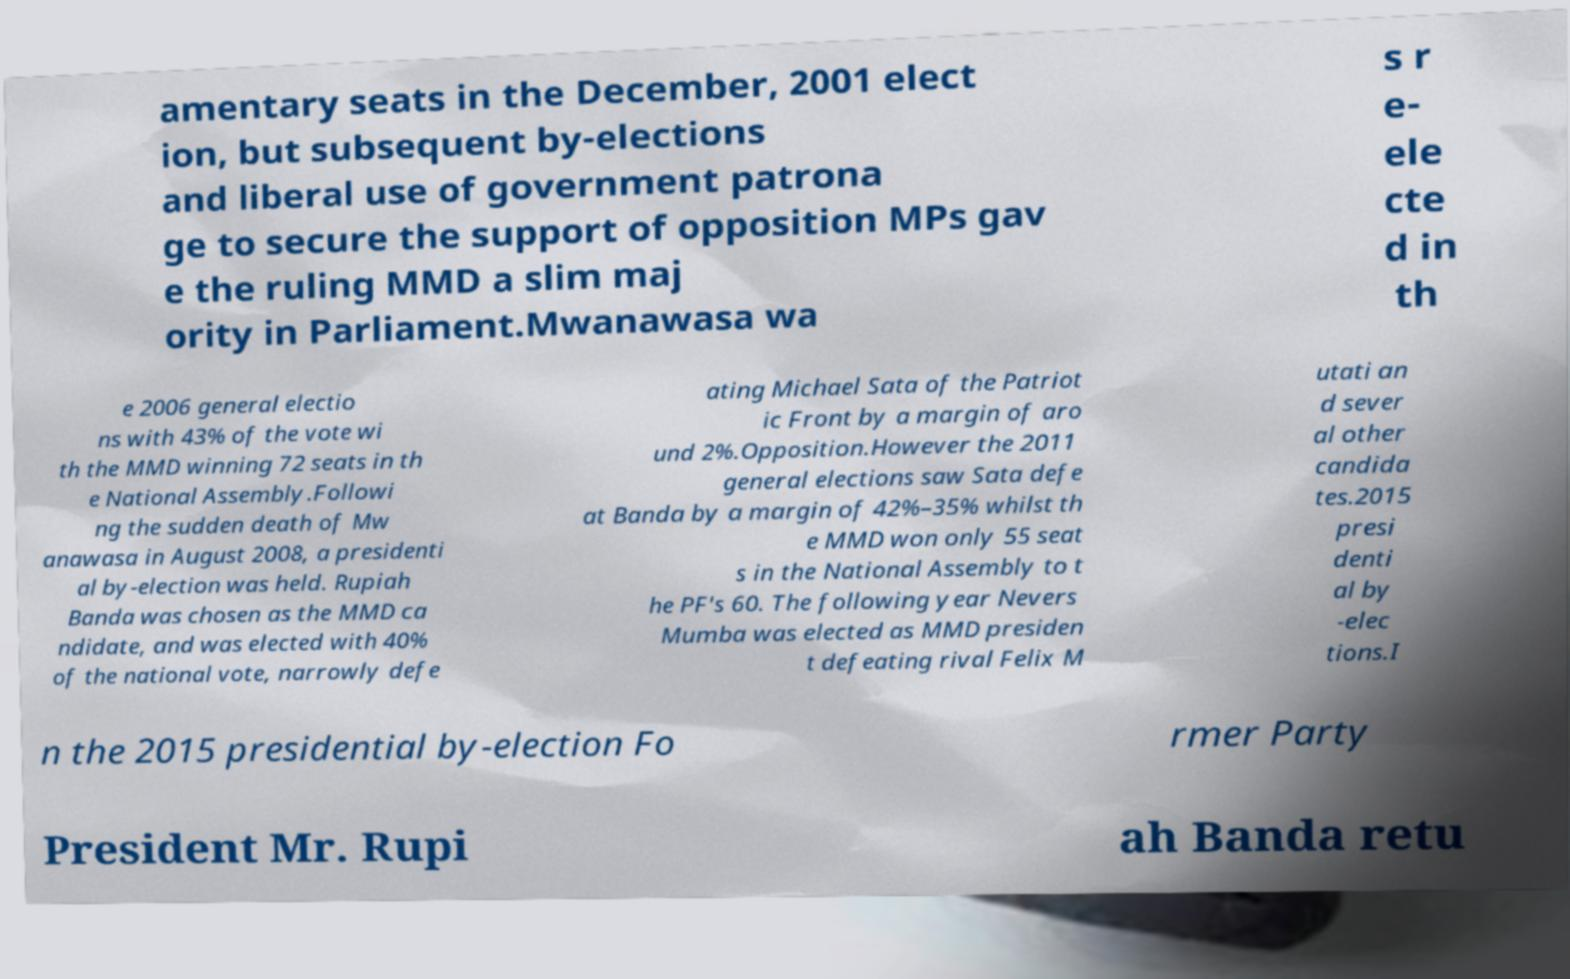Please read and relay the text visible in this image. What does it say? amentary seats in the December, 2001 elect ion, but subsequent by-elections and liberal use of government patrona ge to secure the support of opposition MPs gav e the ruling MMD a slim maj ority in Parliament.Mwanawasa wa s r e- ele cte d in th e 2006 general electio ns with 43% of the vote wi th the MMD winning 72 seats in th e National Assembly.Followi ng the sudden death of Mw anawasa in August 2008, a presidenti al by-election was held. Rupiah Banda was chosen as the MMD ca ndidate, and was elected with 40% of the national vote, narrowly defe ating Michael Sata of the Patriot ic Front by a margin of aro und 2%.Opposition.However the 2011 general elections saw Sata defe at Banda by a margin of 42%–35% whilst th e MMD won only 55 seat s in the National Assembly to t he PF's 60. The following year Nevers Mumba was elected as MMD presiden t defeating rival Felix M utati an d sever al other candida tes.2015 presi denti al by -elec tions.I n the 2015 presidential by-election Fo rmer Party President Mr. Rupi ah Banda retu 